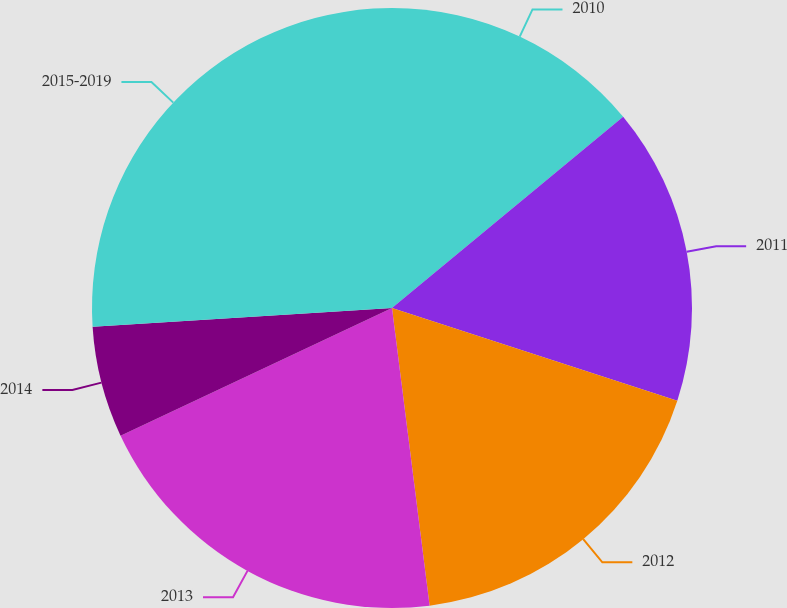<chart> <loc_0><loc_0><loc_500><loc_500><pie_chart><fcel>2010<fcel>2011<fcel>2012<fcel>2013<fcel>2014<fcel>2015-2019<nl><fcel>14.0%<fcel>16.0%<fcel>18.0%<fcel>20.0%<fcel>6.0%<fcel>26.0%<nl></chart> 